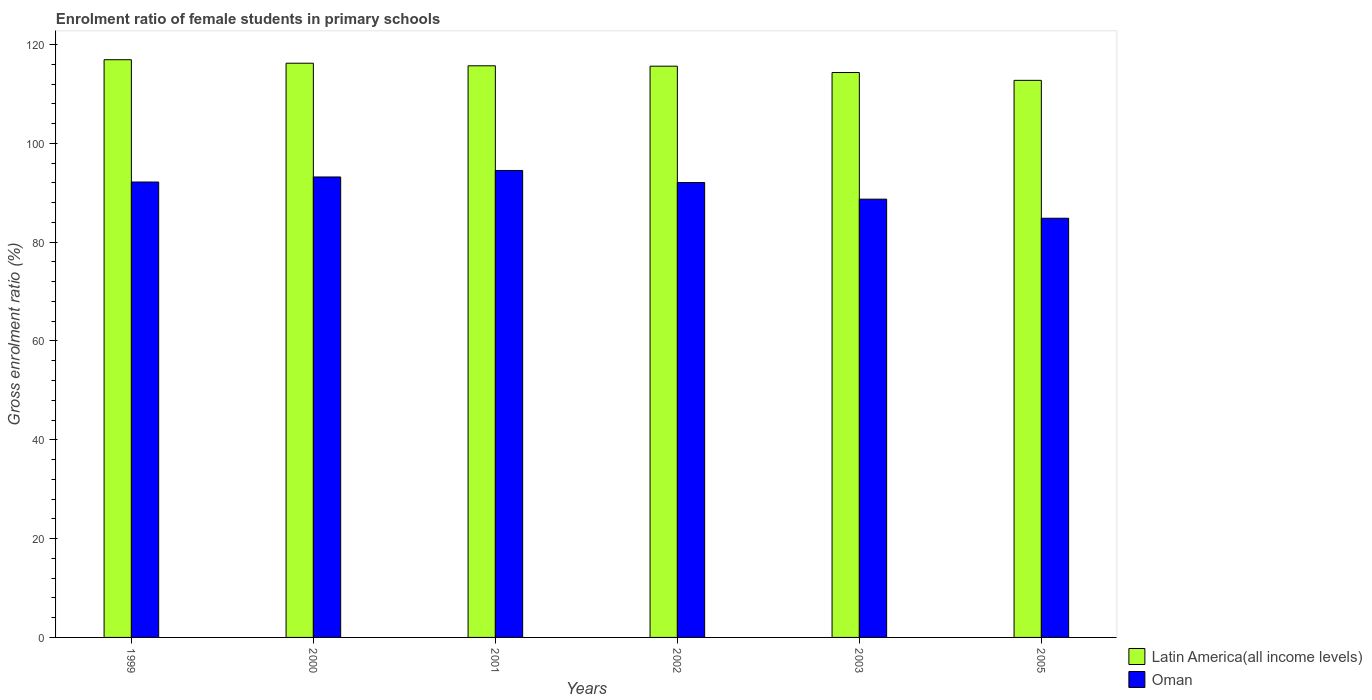How many groups of bars are there?
Provide a succinct answer. 6. What is the enrolment ratio of female students in primary schools in Latin America(all income levels) in 2000?
Make the answer very short. 116.21. Across all years, what is the maximum enrolment ratio of female students in primary schools in Latin America(all income levels)?
Keep it short and to the point. 116.92. Across all years, what is the minimum enrolment ratio of female students in primary schools in Oman?
Give a very brief answer. 84.84. What is the total enrolment ratio of female students in primary schools in Latin America(all income levels) in the graph?
Ensure brevity in your answer.  691.49. What is the difference between the enrolment ratio of female students in primary schools in Oman in 2000 and that in 2003?
Offer a terse response. 4.49. What is the difference between the enrolment ratio of female students in primary schools in Latin America(all income levels) in 2003 and the enrolment ratio of female students in primary schools in Oman in 1999?
Give a very brief answer. 22.16. What is the average enrolment ratio of female students in primary schools in Latin America(all income levels) per year?
Give a very brief answer. 115.25. In the year 2005, what is the difference between the enrolment ratio of female students in primary schools in Latin America(all income levels) and enrolment ratio of female students in primary schools in Oman?
Keep it short and to the point. 27.91. In how many years, is the enrolment ratio of female students in primary schools in Oman greater than 40 %?
Offer a very short reply. 6. What is the ratio of the enrolment ratio of female students in primary schools in Latin America(all income levels) in 2000 to that in 2002?
Ensure brevity in your answer.  1.01. Is the difference between the enrolment ratio of female students in primary schools in Latin America(all income levels) in 2001 and 2005 greater than the difference between the enrolment ratio of female students in primary schools in Oman in 2001 and 2005?
Offer a very short reply. No. What is the difference between the highest and the second highest enrolment ratio of female students in primary schools in Latin America(all income levels)?
Provide a short and direct response. 0.71. What is the difference between the highest and the lowest enrolment ratio of female students in primary schools in Oman?
Your answer should be compact. 9.66. In how many years, is the enrolment ratio of female students in primary schools in Oman greater than the average enrolment ratio of female students in primary schools in Oman taken over all years?
Ensure brevity in your answer.  4. What does the 1st bar from the left in 2005 represents?
Your answer should be compact. Latin America(all income levels). What does the 2nd bar from the right in 2001 represents?
Offer a terse response. Latin America(all income levels). Are all the bars in the graph horizontal?
Keep it short and to the point. No. How many years are there in the graph?
Provide a short and direct response. 6. What is the difference between two consecutive major ticks on the Y-axis?
Offer a very short reply. 20. Are the values on the major ticks of Y-axis written in scientific E-notation?
Provide a short and direct response. No. Does the graph contain any zero values?
Offer a very short reply. No. Does the graph contain grids?
Your answer should be very brief. No. Where does the legend appear in the graph?
Make the answer very short. Bottom right. How many legend labels are there?
Ensure brevity in your answer.  2. How are the legend labels stacked?
Keep it short and to the point. Vertical. What is the title of the graph?
Make the answer very short. Enrolment ratio of female students in primary schools. Does "Iraq" appear as one of the legend labels in the graph?
Provide a succinct answer. No. What is the label or title of the X-axis?
Make the answer very short. Years. What is the label or title of the Y-axis?
Provide a short and direct response. Gross enrolment ratio (%). What is the Gross enrolment ratio (%) in Latin America(all income levels) in 1999?
Offer a terse response. 116.92. What is the Gross enrolment ratio (%) of Oman in 1999?
Your answer should be very brief. 92.17. What is the Gross enrolment ratio (%) in Latin America(all income levels) in 2000?
Give a very brief answer. 116.21. What is the Gross enrolment ratio (%) of Oman in 2000?
Provide a short and direct response. 93.19. What is the Gross enrolment ratio (%) in Latin America(all income levels) in 2001?
Ensure brevity in your answer.  115.69. What is the Gross enrolment ratio (%) in Oman in 2001?
Offer a very short reply. 94.5. What is the Gross enrolment ratio (%) of Latin America(all income levels) in 2002?
Offer a terse response. 115.61. What is the Gross enrolment ratio (%) in Oman in 2002?
Give a very brief answer. 92.07. What is the Gross enrolment ratio (%) of Latin America(all income levels) in 2003?
Offer a very short reply. 114.32. What is the Gross enrolment ratio (%) in Oman in 2003?
Offer a very short reply. 88.7. What is the Gross enrolment ratio (%) in Latin America(all income levels) in 2005?
Your answer should be compact. 112.74. What is the Gross enrolment ratio (%) in Oman in 2005?
Ensure brevity in your answer.  84.84. Across all years, what is the maximum Gross enrolment ratio (%) of Latin America(all income levels)?
Offer a very short reply. 116.92. Across all years, what is the maximum Gross enrolment ratio (%) in Oman?
Offer a very short reply. 94.5. Across all years, what is the minimum Gross enrolment ratio (%) in Latin America(all income levels)?
Offer a terse response. 112.74. Across all years, what is the minimum Gross enrolment ratio (%) in Oman?
Provide a succinct answer. 84.84. What is the total Gross enrolment ratio (%) in Latin America(all income levels) in the graph?
Your answer should be compact. 691.49. What is the total Gross enrolment ratio (%) of Oman in the graph?
Your response must be concise. 545.45. What is the difference between the Gross enrolment ratio (%) in Latin America(all income levels) in 1999 and that in 2000?
Offer a terse response. 0.71. What is the difference between the Gross enrolment ratio (%) in Oman in 1999 and that in 2000?
Provide a short and direct response. -1.02. What is the difference between the Gross enrolment ratio (%) of Latin America(all income levels) in 1999 and that in 2001?
Offer a very short reply. 1.23. What is the difference between the Gross enrolment ratio (%) in Oman in 1999 and that in 2001?
Ensure brevity in your answer.  -2.33. What is the difference between the Gross enrolment ratio (%) in Latin America(all income levels) in 1999 and that in 2002?
Offer a terse response. 1.31. What is the difference between the Gross enrolment ratio (%) in Oman in 1999 and that in 2002?
Offer a terse response. 0.1. What is the difference between the Gross enrolment ratio (%) of Latin America(all income levels) in 1999 and that in 2003?
Keep it short and to the point. 2.59. What is the difference between the Gross enrolment ratio (%) in Oman in 1999 and that in 2003?
Your answer should be very brief. 3.47. What is the difference between the Gross enrolment ratio (%) of Latin America(all income levels) in 1999 and that in 2005?
Give a very brief answer. 4.18. What is the difference between the Gross enrolment ratio (%) of Oman in 1999 and that in 2005?
Give a very brief answer. 7.33. What is the difference between the Gross enrolment ratio (%) of Latin America(all income levels) in 2000 and that in 2001?
Offer a terse response. 0.52. What is the difference between the Gross enrolment ratio (%) of Oman in 2000 and that in 2001?
Give a very brief answer. -1.31. What is the difference between the Gross enrolment ratio (%) in Latin America(all income levels) in 2000 and that in 2002?
Make the answer very short. 0.6. What is the difference between the Gross enrolment ratio (%) in Oman in 2000 and that in 2002?
Provide a succinct answer. 1.12. What is the difference between the Gross enrolment ratio (%) in Latin America(all income levels) in 2000 and that in 2003?
Keep it short and to the point. 1.89. What is the difference between the Gross enrolment ratio (%) in Oman in 2000 and that in 2003?
Make the answer very short. 4.49. What is the difference between the Gross enrolment ratio (%) in Latin America(all income levels) in 2000 and that in 2005?
Offer a very short reply. 3.47. What is the difference between the Gross enrolment ratio (%) of Oman in 2000 and that in 2005?
Your response must be concise. 8.35. What is the difference between the Gross enrolment ratio (%) in Latin America(all income levels) in 2001 and that in 2002?
Give a very brief answer. 0.08. What is the difference between the Gross enrolment ratio (%) of Oman in 2001 and that in 2002?
Offer a very short reply. 2.43. What is the difference between the Gross enrolment ratio (%) in Latin America(all income levels) in 2001 and that in 2003?
Provide a succinct answer. 1.37. What is the difference between the Gross enrolment ratio (%) in Oman in 2001 and that in 2003?
Give a very brief answer. 5.8. What is the difference between the Gross enrolment ratio (%) of Latin America(all income levels) in 2001 and that in 2005?
Ensure brevity in your answer.  2.95. What is the difference between the Gross enrolment ratio (%) of Oman in 2001 and that in 2005?
Ensure brevity in your answer.  9.66. What is the difference between the Gross enrolment ratio (%) of Latin America(all income levels) in 2002 and that in 2003?
Your response must be concise. 1.28. What is the difference between the Gross enrolment ratio (%) of Oman in 2002 and that in 2003?
Your response must be concise. 3.37. What is the difference between the Gross enrolment ratio (%) of Latin America(all income levels) in 2002 and that in 2005?
Provide a short and direct response. 2.87. What is the difference between the Gross enrolment ratio (%) of Oman in 2002 and that in 2005?
Your answer should be very brief. 7.23. What is the difference between the Gross enrolment ratio (%) in Latin America(all income levels) in 2003 and that in 2005?
Keep it short and to the point. 1.58. What is the difference between the Gross enrolment ratio (%) in Oman in 2003 and that in 2005?
Keep it short and to the point. 3.86. What is the difference between the Gross enrolment ratio (%) in Latin America(all income levels) in 1999 and the Gross enrolment ratio (%) in Oman in 2000?
Provide a succinct answer. 23.73. What is the difference between the Gross enrolment ratio (%) of Latin America(all income levels) in 1999 and the Gross enrolment ratio (%) of Oman in 2001?
Keep it short and to the point. 22.42. What is the difference between the Gross enrolment ratio (%) of Latin America(all income levels) in 1999 and the Gross enrolment ratio (%) of Oman in 2002?
Provide a short and direct response. 24.85. What is the difference between the Gross enrolment ratio (%) of Latin America(all income levels) in 1999 and the Gross enrolment ratio (%) of Oman in 2003?
Provide a succinct answer. 28.22. What is the difference between the Gross enrolment ratio (%) of Latin America(all income levels) in 1999 and the Gross enrolment ratio (%) of Oman in 2005?
Give a very brief answer. 32.08. What is the difference between the Gross enrolment ratio (%) of Latin America(all income levels) in 2000 and the Gross enrolment ratio (%) of Oman in 2001?
Provide a succinct answer. 21.71. What is the difference between the Gross enrolment ratio (%) in Latin America(all income levels) in 2000 and the Gross enrolment ratio (%) in Oman in 2002?
Provide a succinct answer. 24.14. What is the difference between the Gross enrolment ratio (%) in Latin America(all income levels) in 2000 and the Gross enrolment ratio (%) in Oman in 2003?
Keep it short and to the point. 27.51. What is the difference between the Gross enrolment ratio (%) in Latin America(all income levels) in 2000 and the Gross enrolment ratio (%) in Oman in 2005?
Keep it short and to the point. 31.37. What is the difference between the Gross enrolment ratio (%) in Latin America(all income levels) in 2001 and the Gross enrolment ratio (%) in Oman in 2002?
Ensure brevity in your answer.  23.62. What is the difference between the Gross enrolment ratio (%) of Latin America(all income levels) in 2001 and the Gross enrolment ratio (%) of Oman in 2003?
Provide a succinct answer. 26.99. What is the difference between the Gross enrolment ratio (%) in Latin America(all income levels) in 2001 and the Gross enrolment ratio (%) in Oman in 2005?
Provide a short and direct response. 30.85. What is the difference between the Gross enrolment ratio (%) of Latin America(all income levels) in 2002 and the Gross enrolment ratio (%) of Oman in 2003?
Your answer should be very brief. 26.91. What is the difference between the Gross enrolment ratio (%) of Latin America(all income levels) in 2002 and the Gross enrolment ratio (%) of Oman in 2005?
Provide a short and direct response. 30.77. What is the difference between the Gross enrolment ratio (%) of Latin America(all income levels) in 2003 and the Gross enrolment ratio (%) of Oman in 2005?
Keep it short and to the point. 29.49. What is the average Gross enrolment ratio (%) of Latin America(all income levels) per year?
Keep it short and to the point. 115.25. What is the average Gross enrolment ratio (%) of Oman per year?
Provide a succinct answer. 90.91. In the year 1999, what is the difference between the Gross enrolment ratio (%) of Latin America(all income levels) and Gross enrolment ratio (%) of Oman?
Provide a short and direct response. 24.75. In the year 2000, what is the difference between the Gross enrolment ratio (%) in Latin America(all income levels) and Gross enrolment ratio (%) in Oman?
Ensure brevity in your answer.  23.02. In the year 2001, what is the difference between the Gross enrolment ratio (%) of Latin America(all income levels) and Gross enrolment ratio (%) of Oman?
Offer a very short reply. 21.19. In the year 2002, what is the difference between the Gross enrolment ratio (%) in Latin America(all income levels) and Gross enrolment ratio (%) in Oman?
Provide a short and direct response. 23.54. In the year 2003, what is the difference between the Gross enrolment ratio (%) in Latin America(all income levels) and Gross enrolment ratio (%) in Oman?
Keep it short and to the point. 25.63. In the year 2005, what is the difference between the Gross enrolment ratio (%) of Latin America(all income levels) and Gross enrolment ratio (%) of Oman?
Give a very brief answer. 27.91. What is the ratio of the Gross enrolment ratio (%) in Latin America(all income levels) in 1999 to that in 2000?
Keep it short and to the point. 1.01. What is the ratio of the Gross enrolment ratio (%) in Oman in 1999 to that in 2000?
Ensure brevity in your answer.  0.99. What is the ratio of the Gross enrolment ratio (%) of Latin America(all income levels) in 1999 to that in 2001?
Make the answer very short. 1.01. What is the ratio of the Gross enrolment ratio (%) in Oman in 1999 to that in 2001?
Keep it short and to the point. 0.98. What is the ratio of the Gross enrolment ratio (%) in Latin America(all income levels) in 1999 to that in 2002?
Ensure brevity in your answer.  1.01. What is the ratio of the Gross enrolment ratio (%) in Latin America(all income levels) in 1999 to that in 2003?
Give a very brief answer. 1.02. What is the ratio of the Gross enrolment ratio (%) in Oman in 1999 to that in 2003?
Offer a terse response. 1.04. What is the ratio of the Gross enrolment ratio (%) of Oman in 1999 to that in 2005?
Your answer should be compact. 1.09. What is the ratio of the Gross enrolment ratio (%) in Oman in 2000 to that in 2001?
Ensure brevity in your answer.  0.99. What is the ratio of the Gross enrolment ratio (%) in Latin America(all income levels) in 2000 to that in 2002?
Offer a very short reply. 1.01. What is the ratio of the Gross enrolment ratio (%) of Oman in 2000 to that in 2002?
Give a very brief answer. 1.01. What is the ratio of the Gross enrolment ratio (%) in Latin America(all income levels) in 2000 to that in 2003?
Your response must be concise. 1.02. What is the ratio of the Gross enrolment ratio (%) in Oman in 2000 to that in 2003?
Make the answer very short. 1.05. What is the ratio of the Gross enrolment ratio (%) in Latin America(all income levels) in 2000 to that in 2005?
Your answer should be very brief. 1.03. What is the ratio of the Gross enrolment ratio (%) of Oman in 2000 to that in 2005?
Ensure brevity in your answer.  1.1. What is the ratio of the Gross enrolment ratio (%) in Oman in 2001 to that in 2002?
Make the answer very short. 1.03. What is the ratio of the Gross enrolment ratio (%) of Latin America(all income levels) in 2001 to that in 2003?
Make the answer very short. 1.01. What is the ratio of the Gross enrolment ratio (%) of Oman in 2001 to that in 2003?
Provide a short and direct response. 1.07. What is the ratio of the Gross enrolment ratio (%) in Latin America(all income levels) in 2001 to that in 2005?
Your answer should be compact. 1.03. What is the ratio of the Gross enrolment ratio (%) of Oman in 2001 to that in 2005?
Keep it short and to the point. 1.11. What is the ratio of the Gross enrolment ratio (%) in Latin America(all income levels) in 2002 to that in 2003?
Keep it short and to the point. 1.01. What is the ratio of the Gross enrolment ratio (%) of Oman in 2002 to that in 2003?
Provide a short and direct response. 1.04. What is the ratio of the Gross enrolment ratio (%) of Latin America(all income levels) in 2002 to that in 2005?
Offer a terse response. 1.03. What is the ratio of the Gross enrolment ratio (%) of Oman in 2002 to that in 2005?
Provide a short and direct response. 1.09. What is the ratio of the Gross enrolment ratio (%) in Latin America(all income levels) in 2003 to that in 2005?
Ensure brevity in your answer.  1.01. What is the ratio of the Gross enrolment ratio (%) of Oman in 2003 to that in 2005?
Offer a terse response. 1.05. What is the difference between the highest and the second highest Gross enrolment ratio (%) of Latin America(all income levels)?
Your answer should be compact. 0.71. What is the difference between the highest and the second highest Gross enrolment ratio (%) of Oman?
Offer a terse response. 1.31. What is the difference between the highest and the lowest Gross enrolment ratio (%) in Latin America(all income levels)?
Offer a terse response. 4.18. What is the difference between the highest and the lowest Gross enrolment ratio (%) in Oman?
Offer a very short reply. 9.66. 